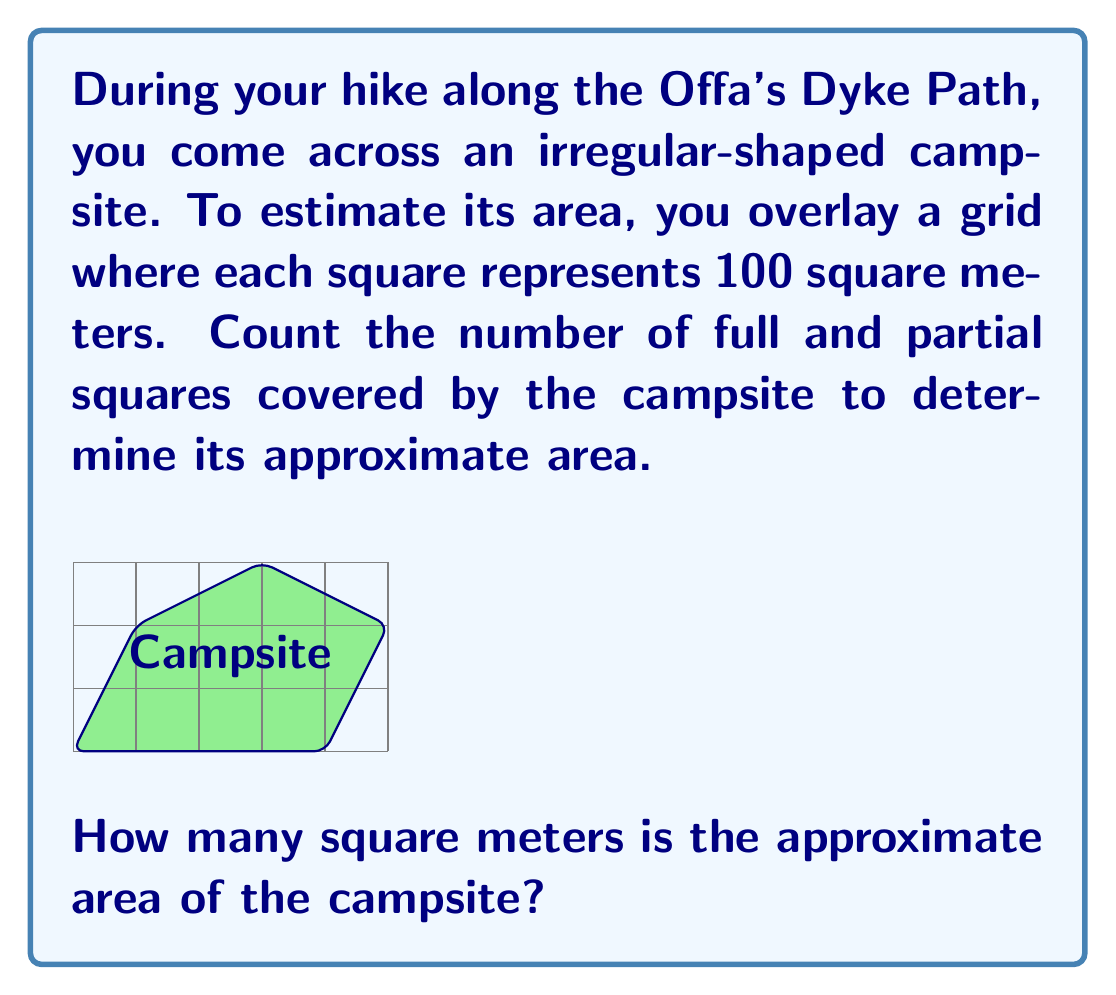What is the answer to this math problem? To solve this problem, we need to count the number of squares (both full and partial) covered by the campsite and multiply by the area each square represents. Let's break it down step-by-step:

1) Count full squares:
   There are 6 full squares completely within the campsite.

2) Count partial squares:
   There are 9 partial squares that the campsite boundary crosses.

3) For irregular shapes, a common estimation technique is to count each partial square as half a square:
   Partial square contribution = 9 ÷ 2 = 4.5

4) Total square count:
   Full squares + Partial squares = 6 + 4.5 = 10.5

5) Calculate the area:
   Each square represents 100 m², so:
   Area = 10.5 × 100 m² = 1050 m²

Therefore, the approximate area of the campsite is 1050 square meters.
Answer: 1050 m² 